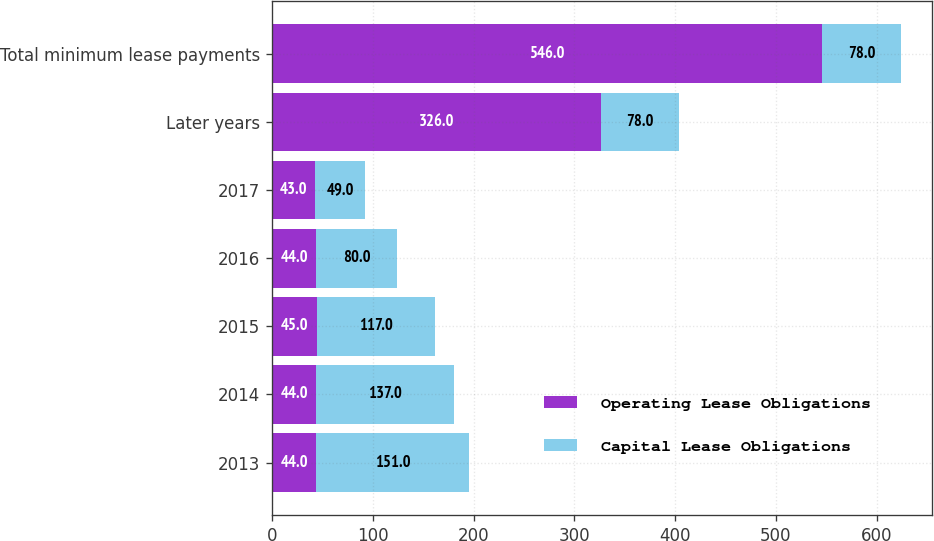Convert chart to OTSL. <chart><loc_0><loc_0><loc_500><loc_500><stacked_bar_chart><ecel><fcel>2013<fcel>2014<fcel>2015<fcel>2016<fcel>2017<fcel>Later years<fcel>Total minimum lease payments<nl><fcel>Operating Lease Obligations<fcel>44<fcel>44<fcel>45<fcel>44<fcel>43<fcel>326<fcel>546<nl><fcel>Capital Lease Obligations<fcel>151<fcel>137<fcel>117<fcel>80<fcel>49<fcel>78<fcel>78<nl></chart> 